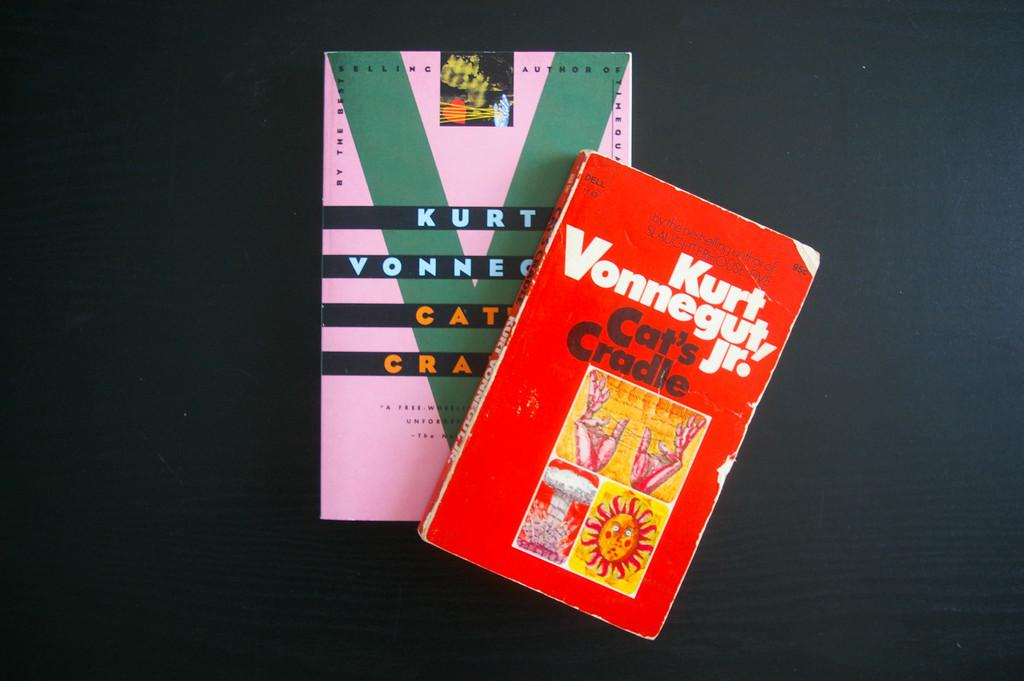<image>
Relay a brief, clear account of the picture shown. Kurt Vonnegut, Jr. book sits on a black table with another book. 